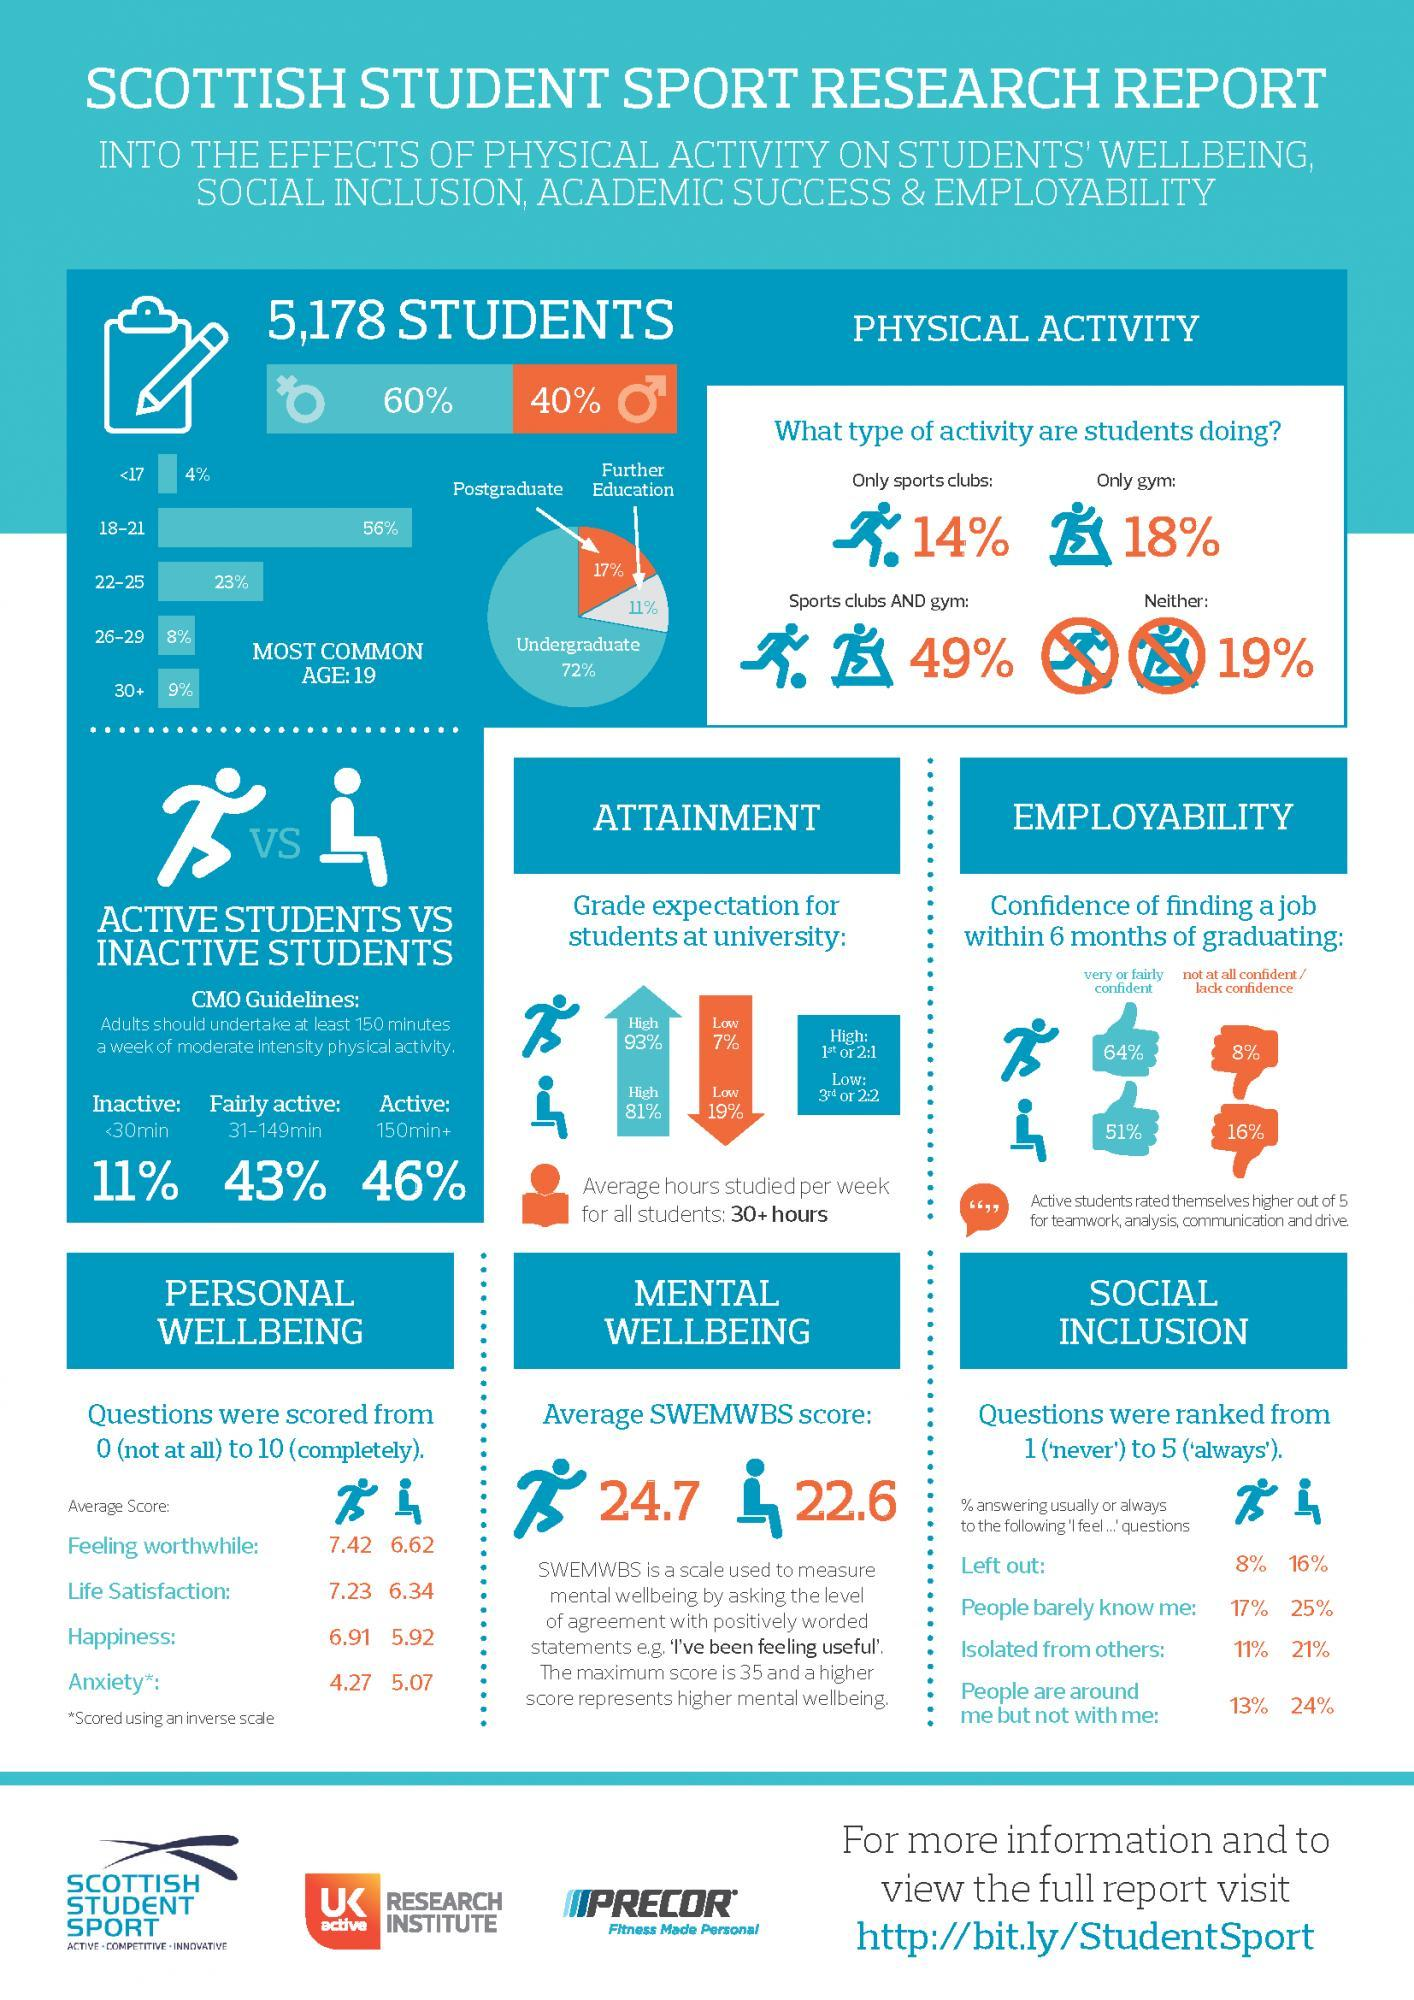What % of the 5178 students are males
Answer the question with a short phrase. 40% What % of students are under the age group of 26+ 17 What % of the 5178 students are females 60% What % of the inactive students felt  isolated from others 21% What percentage of students are not going to sports clubs or gym 19% what was the average score of active students for life satisfaction 7.23 what was the SWEMWBS score for inactive students 22.6 